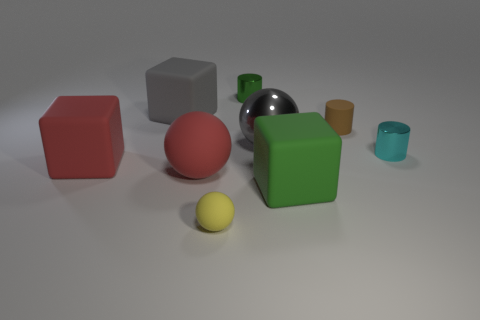Are any big gray matte things visible?
Your answer should be very brief. Yes. How many other things are there of the same size as the brown object?
Provide a short and direct response. 3. Do the large rubber block that is behind the big metal object and the tiny shiny cylinder left of the cyan metallic thing have the same color?
Your answer should be very brief. No. What is the size of the brown thing that is the same shape as the cyan thing?
Provide a succinct answer. Small. Are the large sphere that is on the left side of the yellow ball and the cube that is behind the big red matte block made of the same material?
Provide a succinct answer. Yes. How many matte things are yellow blocks or big green blocks?
Give a very brief answer. 1. The small thing in front of the small metallic cylinder that is to the right of the cylinder left of the green cube is made of what material?
Offer a terse response. Rubber. Does the tiny rubber thing that is on the right side of the yellow rubber object have the same shape as the thing in front of the large green matte block?
Make the answer very short. No. What color is the large rubber object behind the tiny metallic object right of the brown rubber thing?
Provide a succinct answer. Gray. What number of blocks are either large things or big green things?
Your response must be concise. 3. 